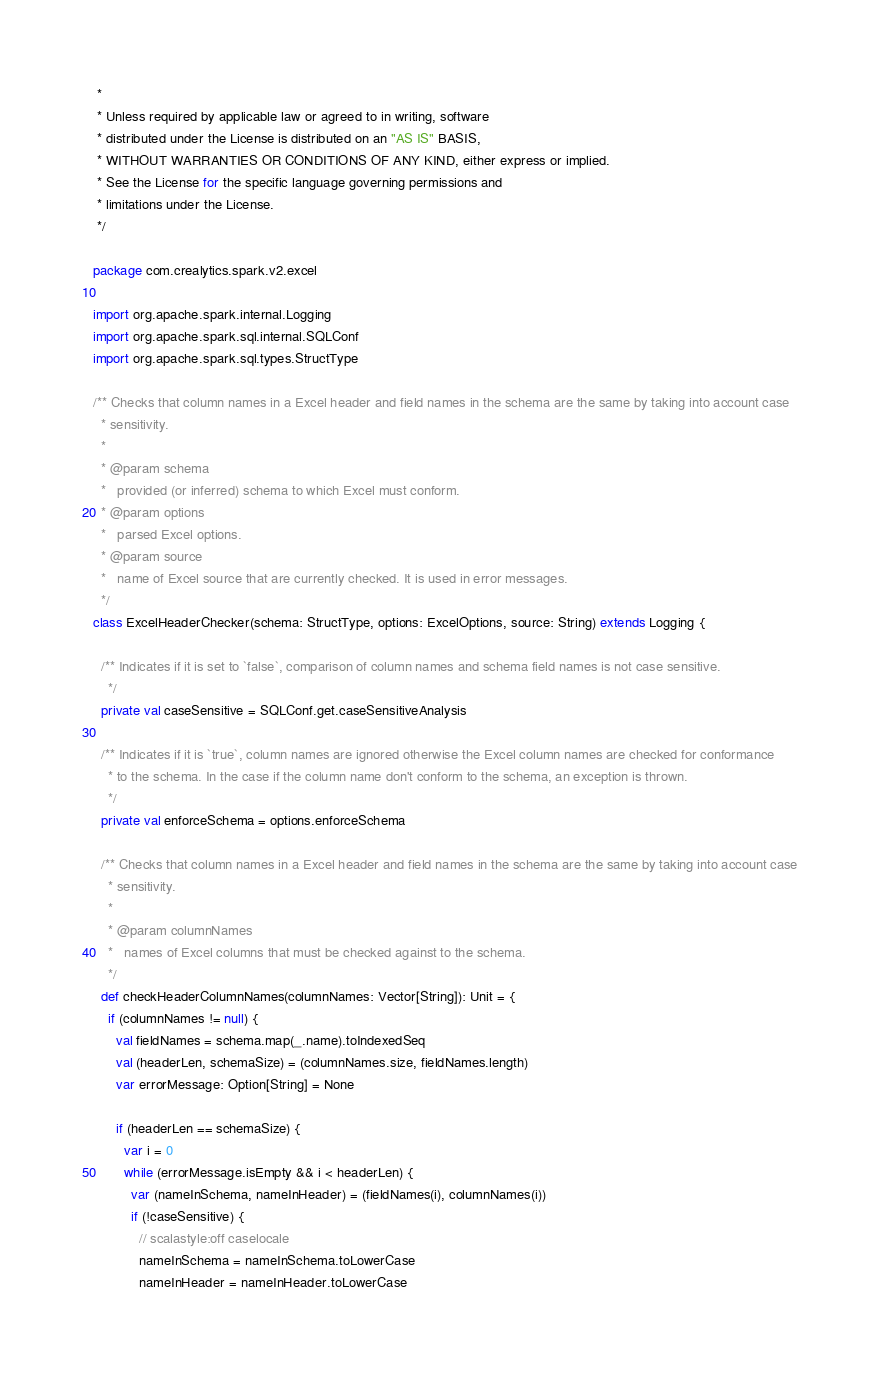Convert code to text. <code><loc_0><loc_0><loc_500><loc_500><_Scala_> *
 * Unless required by applicable law or agreed to in writing, software
 * distributed under the License is distributed on an "AS IS" BASIS,
 * WITHOUT WARRANTIES OR CONDITIONS OF ANY KIND, either express or implied.
 * See the License for the specific language governing permissions and
 * limitations under the License.
 */

package com.crealytics.spark.v2.excel

import org.apache.spark.internal.Logging
import org.apache.spark.sql.internal.SQLConf
import org.apache.spark.sql.types.StructType

/** Checks that column names in a Excel header and field names in the schema are the same by taking into account case
  * sensitivity.
  *
  * @param schema
  *   provided (or inferred) schema to which Excel must conform.
  * @param options
  *   parsed Excel options.
  * @param source
  *   name of Excel source that are currently checked. It is used in error messages.
  */
class ExcelHeaderChecker(schema: StructType, options: ExcelOptions, source: String) extends Logging {

  /** Indicates if it is set to `false`, comparison of column names and schema field names is not case sensitive.
    */
  private val caseSensitive = SQLConf.get.caseSensitiveAnalysis

  /** Indicates if it is `true`, column names are ignored otherwise the Excel column names are checked for conformance
    * to the schema. In the case if the column name don't conform to the schema, an exception is thrown.
    */
  private val enforceSchema = options.enforceSchema

  /** Checks that column names in a Excel header and field names in the schema are the same by taking into account case
    * sensitivity.
    *
    * @param columnNames
    *   names of Excel columns that must be checked against to the schema.
    */
  def checkHeaderColumnNames(columnNames: Vector[String]): Unit = {
    if (columnNames != null) {
      val fieldNames = schema.map(_.name).toIndexedSeq
      val (headerLen, schemaSize) = (columnNames.size, fieldNames.length)
      var errorMessage: Option[String] = None

      if (headerLen == schemaSize) {
        var i = 0
        while (errorMessage.isEmpty && i < headerLen) {
          var (nameInSchema, nameInHeader) = (fieldNames(i), columnNames(i))
          if (!caseSensitive) {
            // scalastyle:off caselocale
            nameInSchema = nameInSchema.toLowerCase
            nameInHeader = nameInHeader.toLowerCase</code> 